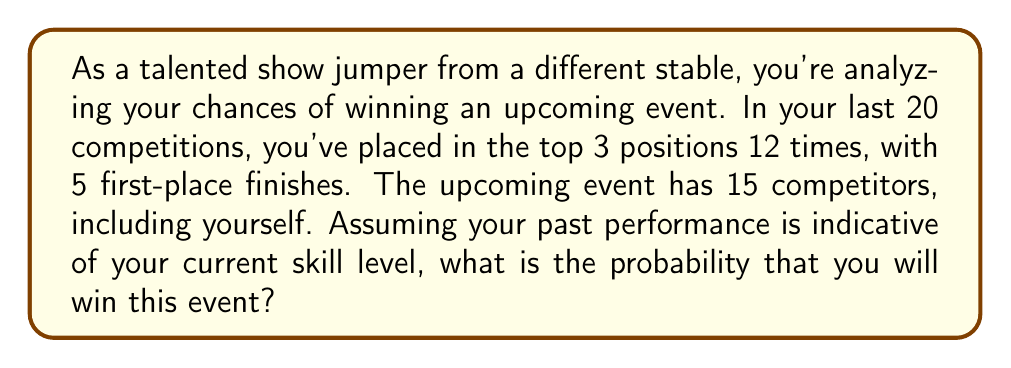What is the answer to this math problem? Let's approach this step-by-step:

1) First, we need to calculate your probability of winning a single event based on your past performance:

   $P(\text{winning}) = \frac{\text{Number of wins}}{\text{Total competitions}} = \frac{5}{20} = 0.25$ or $25\%$

2) However, this probability doesn't take into account the number of competitors. We need to adjust for this.

3) In a competition with 15 riders, if all riders were equally skilled, each would have a $\frac{1}{15}$ chance of winning.

4) We can use the concept of odds ratio to compare your chances to the average:

   $\text{Odds Ratio} = \frac{\text{Your probability of winning}}{1 - \text{Your probability of winning}} \div \frac{1/15}{1 - 1/15}$

5) Let's calculate this:

   $\text{Odds Ratio} = \frac{0.25}{0.75} \div \frac{1/15}{14/15} = \frac{0.25}{0.75} \times \frac{14}{1} = 4.67$

6) This means you're 4.67 times more likely to win than an average competitor.

7) To convert this back to a probability, we use:

   $P(\text{winning}) = \frac{\text{Odds Ratio}}{\text{Odds Ratio} + (\text{Number of competitors} - 1)}$

8) Plugging in our values:

   $P(\text{winning}) = \frac{4.67}{4.67 + (15 - 1)} = \frac{4.67}{18.67} \approx 0.25$ or $25\%$

Therefore, based on your past performance and the number of competitors, your estimated probability of winning is approximately 25%.
Answer: The probability of winning the upcoming event is approximately $0.25$ or $25\%$. 